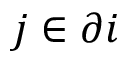<formula> <loc_0><loc_0><loc_500><loc_500>j \in \partial i</formula> 